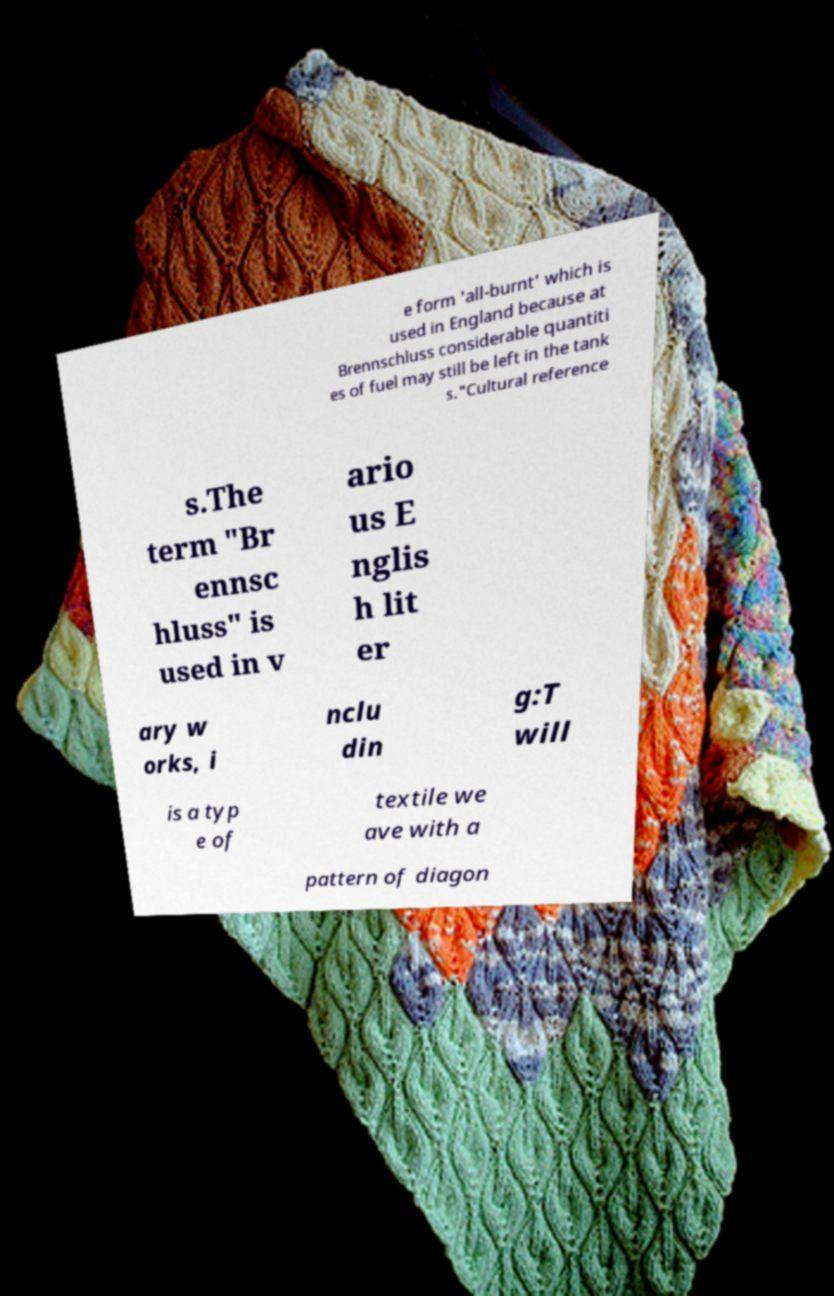Please identify and transcribe the text found in this image. e form 'all-burnt' which is used in England because at Brennschluss considerable quantiti es of fuel may still be left in the tank s."Cultural reference s.The term "Br ennsc hluss" is used in v ario us E nglis h lit er ary w orks, i nclu din g:T will is a typ e of textile we ave with a pattern of diagon 